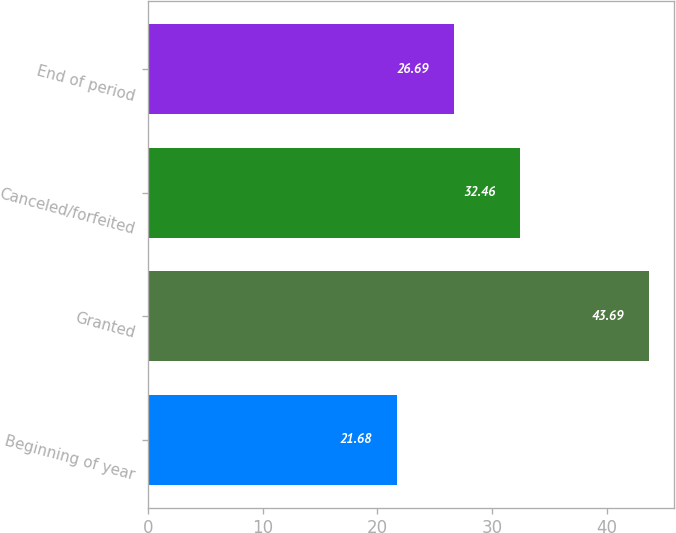<chart> <loc_0><loc_0><loc_500><loc_500><bar_chart><fcel>Beginning of year<fcel>Granted<fcel>Canceled/forfeited<fcel>End of period<nl><fcel>21.68<fcel>43.69<fcel>32.46<fcel>26.69<nl></chart> 